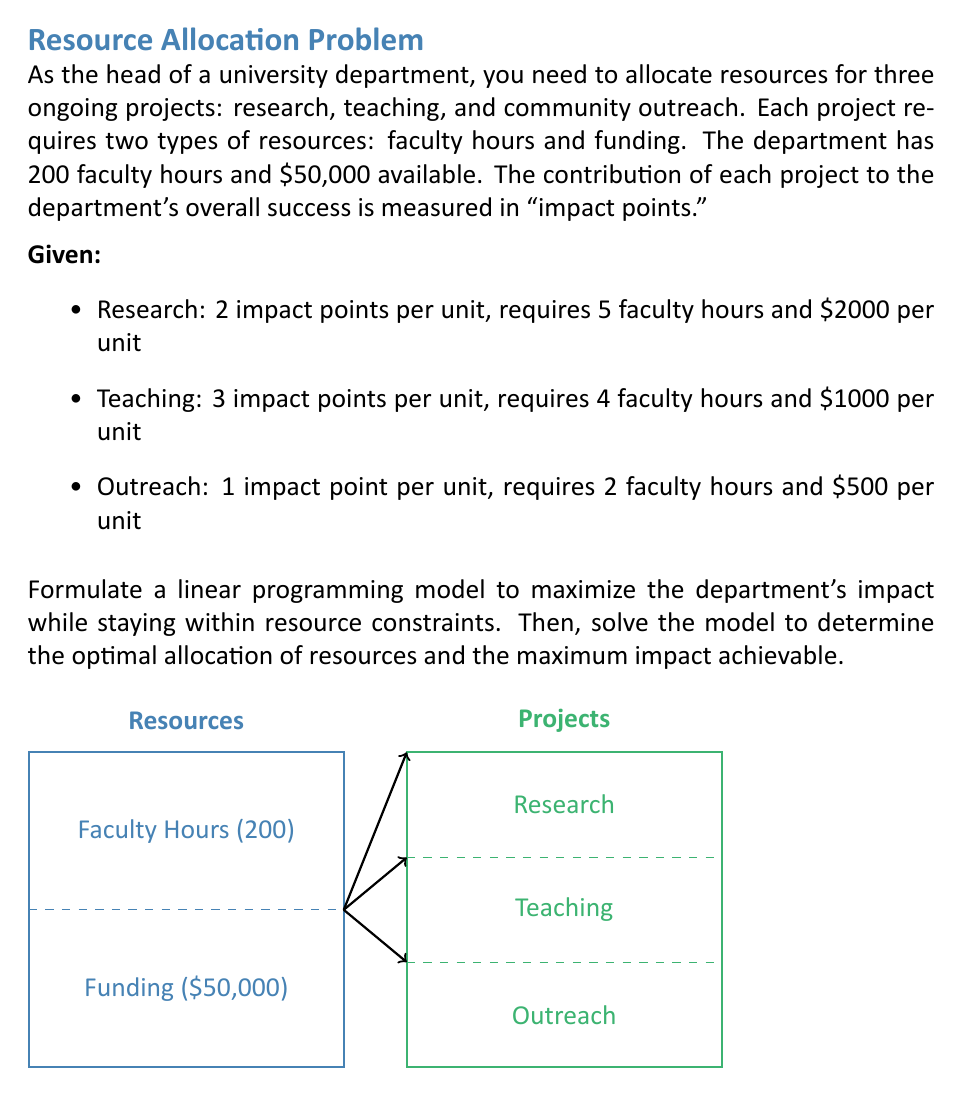Can you answer this question? Let's solve this problem step by step:

1) Define variables:
   Let $x$ = units of research
       $y$ = units of teaching
       $z$ = units of outreach

2) Formulate the objective function:
   Maximize Impact = $2x + 3y + z$

3) Identify constraints:
   a) Faculty hours: $5x + 4y + 2z \leq 200$
   b) Funding: $2000x + 1000y + 500z \leq 50000$
   c) Non-negativity: $x, y, z \geq 0$

4) The complete linear programming model:

   Maximize $2x + 3y + z$
   Subject to:
   $5x + 4y + 2z \leq 200$
   $2000x + 1000y + 500z \leq 50000$
   $x, y, z \geq 0$

5) To solve this, we can use the simplex method or a linear programming solver. However, for this explanation, let's use the graphical method by reducing it to two variables.

6) Observe that the funding constraint can be simplified:
   $2000x + 1000y + 500z \leq 50000$
   $4x + 2y + z \leq 100$

7) If we assume $z = 0$ (no outreach), we can graph the constraints:
   $5x + 4y \leq 200$
   $4x + 2y \leq 100$

8) Plotting these lines and the objective function, we find that the optimal solution occurs at the intersection of these two lines:

   $5x + 4y = 200$
   $4x + 2y = 100$

9) Solving these equations:
   $10x + 8y = 400$
   $12x + 6y = 300$
   Subtracting, we get: $-2x + 2y = 100$
   $x + y = 50$
   Substituting back: $5(50-y) + 4y = 200$
   $250 - 5y + 4y = 200$
   $-y = -50$
   $y = 50$

   Therefore, $x = 0$

10) The optimal solution is $x = 0$, $y = 50$, $z = 0$

11) Maximum impact = $2(0) + 3(50) + 1(0) = 150$ impact points
Answer: Optimal allocation: 50 units of teaching. Maximum impact: 150 points. 